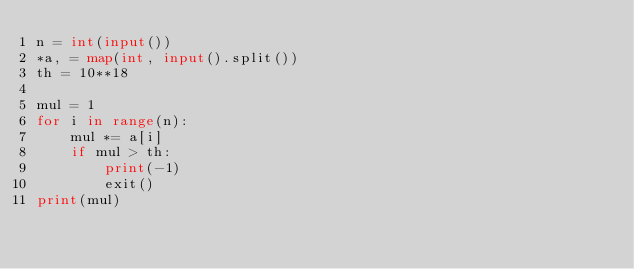Convert code to text. <code><loc_0><loc_0><loc_500><loc_500><_Python_>n = int(input())
*a, = map(int, input().split())
th = 10**18

mul = 1
for i in range(n):
    mul *= a[i]
    if mul > th:
        print(-1)
        exit()
print(mul)
</code> 